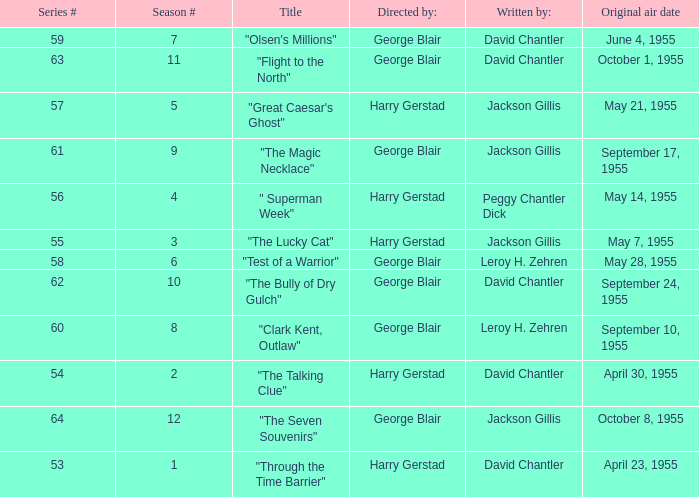Which Season originally aired on September 17, 1955 9.0. Give me the full table as a dictionary. {'header': ['Series #', 'Season #', 'Title', 'Directed by:', 'Written by:', 'Original air date'], 'rows': [['59', '7', '"Olsen\'s Millions"', 'George Blair', 'David Chantler', 'June 4, 1955'], ['63', '11', '"Flight to the North"', 'George Blair', 'David Chantler', 'October 1, 1955'], ['57', '5', '"Great Caesar\'s Ghost"', 'Harry Gerstad', 'Jackson Gillis', 'May 21, 1955'], ['61', '9', '"The Magic Necklace"', 'George Blair', 'Jackson Gillis', 'September 17, 1955'], ['56', '4', '" Superman Week"', 'Harry Gerstad', 'Peggy Chantler Dick', 'May 14, 1955'], ['55', '3', '"The Lucky Cat"', 'Harry Gerstad', 'Jackson Gillis', 'May 7, 1955'], ['58', '6', '"Test of a Warrior"', 'George Blair', 'Leroy H. Zehren', 'May 28, 1955'], ['62', '10', '"The Bully of Dry Gulch"', 'George Blair', 'David Chantler', 'September 24, 1955'], ['60', '8', '"Clark Kent, Outlaw"', 'George Blair', 'Leroy H. Zehren', 'September 10, 1955'], ['54', '2', '"The Talking Clue"', 'Harry Gerstad', 'David Chantler', 'April 30, 1955'], ['64', '12', '"The Seven Souvenirs"', 'George Blair', 'Jackson Gillis', 'October 8, 1955'], ['53', '1', '"Through the Time Barrier"', 'Harry Gerstad', 'David Chantler', 'April 23, 1955']]} 